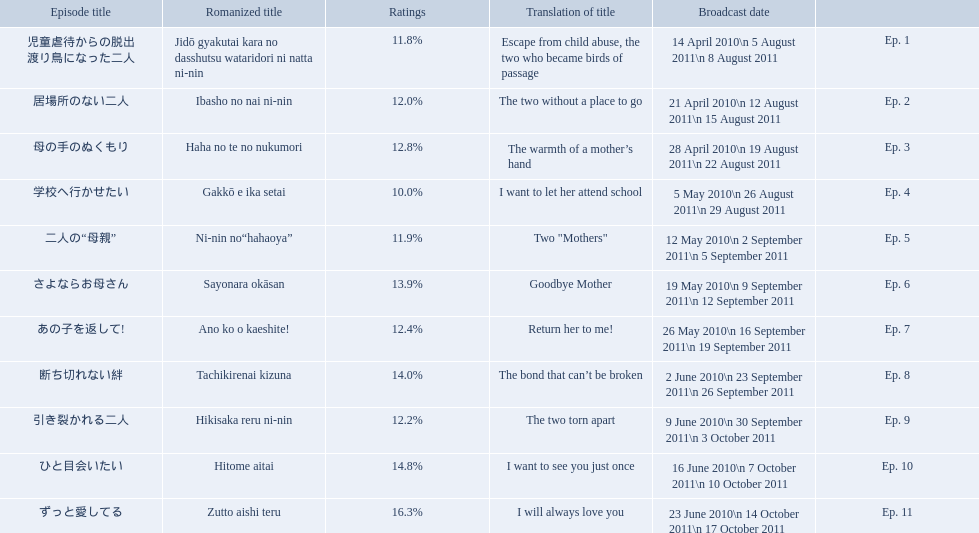Which episode had the highest ratings? Ep. 11. Which episode was named haha no te no nukumori? Ep. 3. Besides episode 10 which episode had a 14% rating? Ep. 8. 